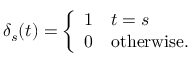<formula> <loc_0><loc_0><loc_500><loc_500>\delta _ { s } ( t ) = { \left \{ \begin{array} { l l } { 1 } & { t = s } \\ { 0 } & { o t h e r w i s e . } \end{array} }</formula> 